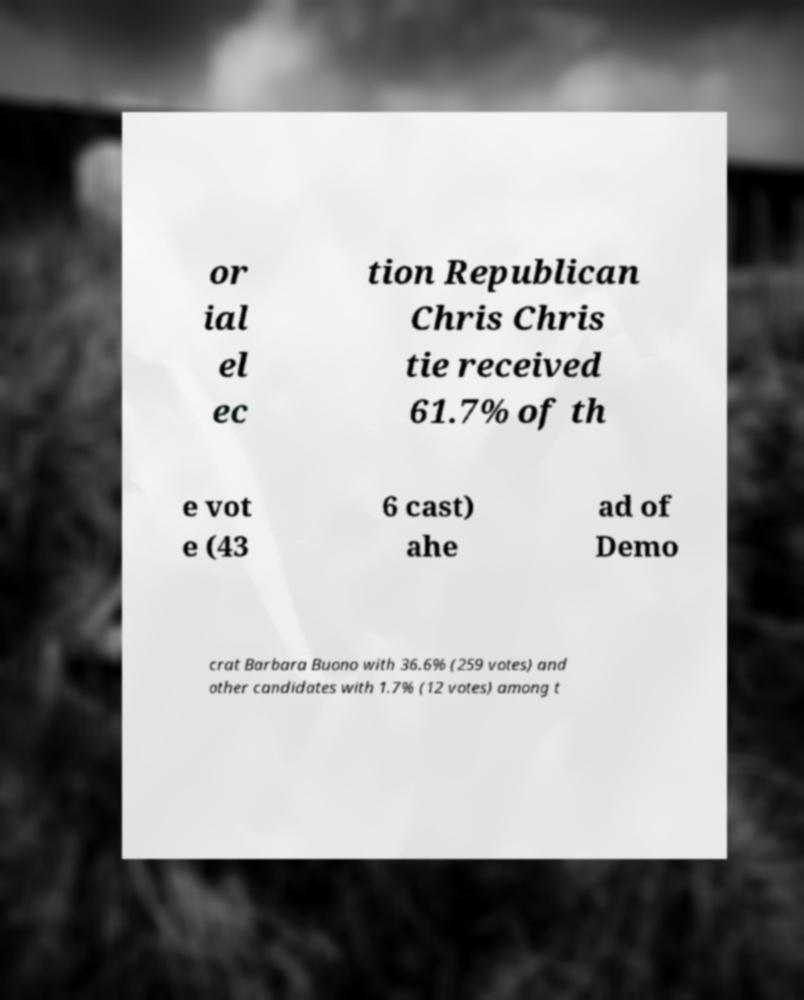Please identify and transcribe the text found in this image. or ial el ec tion Republican Chris Chris tie received 61.7% of th e vot e (43 6 cast) ahe ad of Demo crat Barbara Buono with 36.6% (259 votes) and other candidates with 1.7% (12 votes) among t 